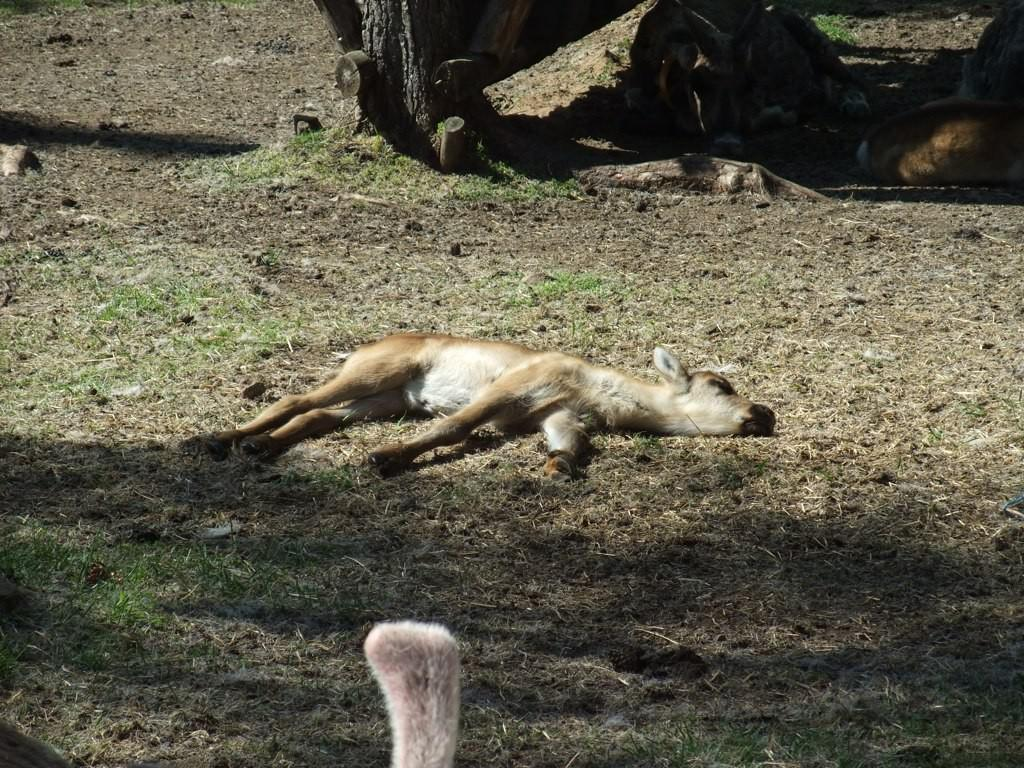What type of creature is in the image? There is an animal in the image. What is the animal doing in the image? The animal is sleeping on the ground. What color is the animal in the image? The animal is brown in color. What can be seen in the background of the image? The background of the image includes grass. What color is the grass in the image? The grass is green in color. Can you hear the animal whistling in the image? There is no indication of sound in the image, so it cannot be determined if the animal is whistling or not. 